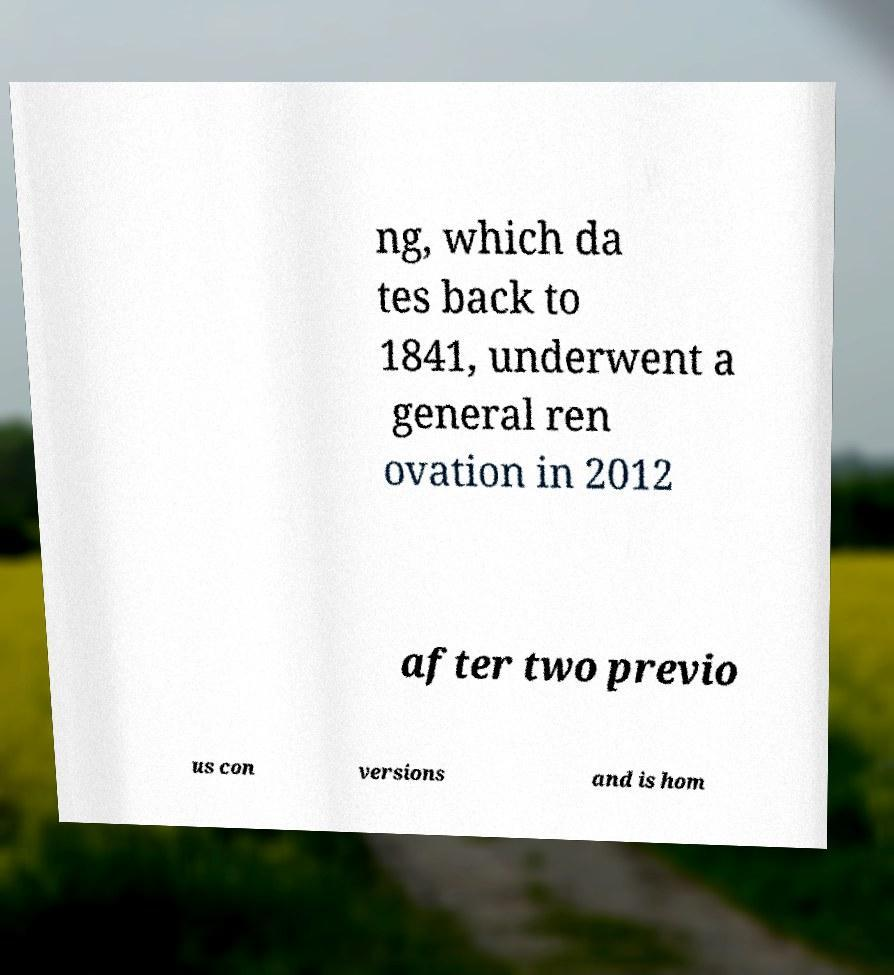What messages or text are displayed in this image? I need them in a readable, typed format. ng, which da tes back to 1841, underwent a general ren ovation in 2012 after two previo us con versions and is hom 